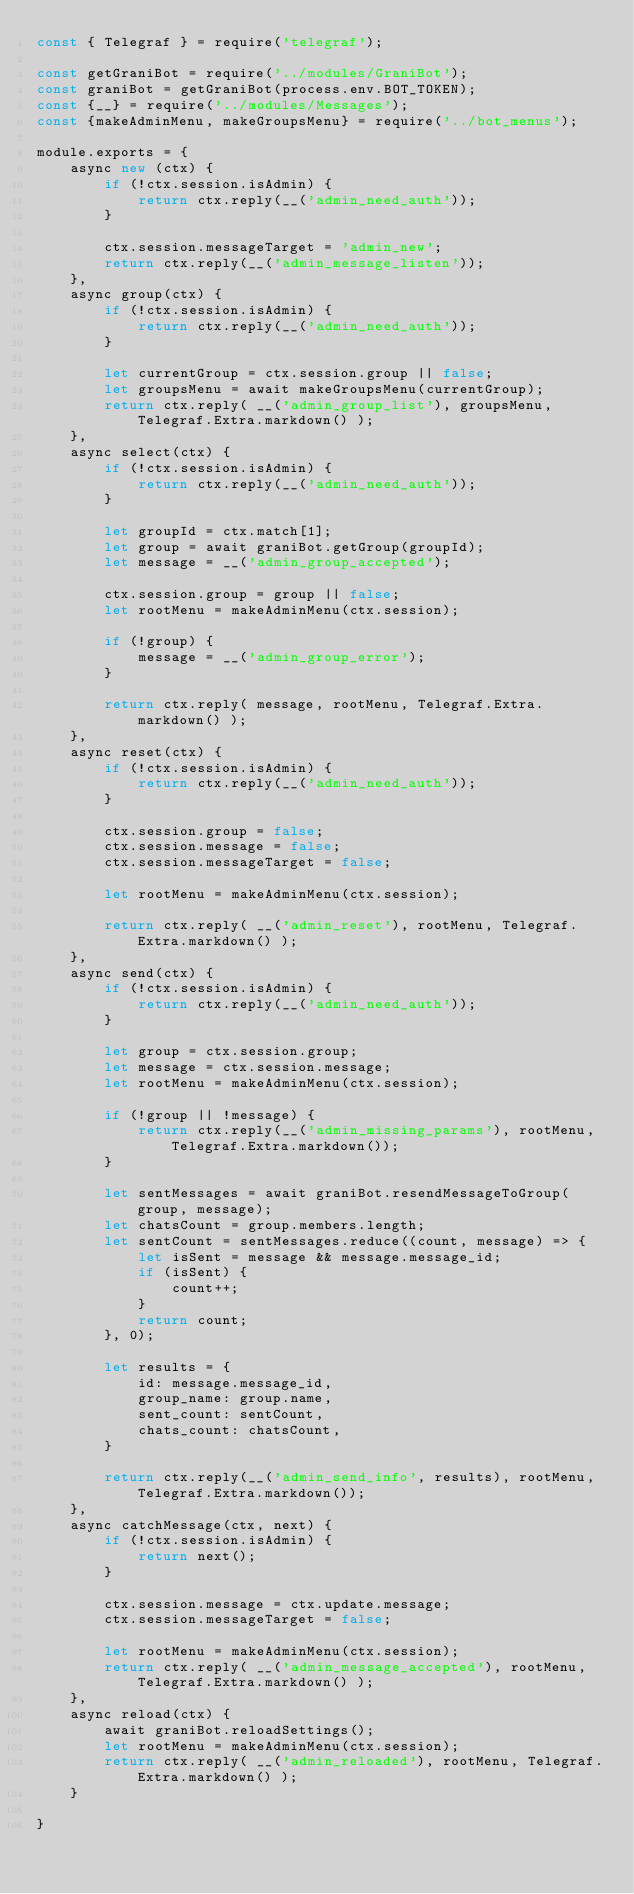<code> <loc_0><loc_0><loc_500><loc_500><_JavaScript_>const { Telegraf } = require('telegraf');

const getGraniBot = require('../modules/GraniBot');
const graniBot = getGraniBot(process.env.BOT_TOKEN);
const {__} = require('../modules/Messages');
const {makeAdminMenu, makeGroupsMenu} = require('../bot_menus');

module.exports = {
    async new (ctx) {
        if (!ctx.session.isAdmin) {
            return ctx.reply(__('admin_need_auth'));
        }

        ctx.session.messageTarget = 'admin_new';
        return ctx.reply(__('admin_message_listen'));
    },
    async group(ctx) {
        if (!ctx.session.isAdmin) {
            return ctx.reply(__('admin_need_auth'));
        }

        let currentGroup = ctx.session.group || false;
        let groupsMenu = await makeGroupsMenu(currentGroup);
        return ctx.reply( __('admin_group_list'), groupsMenu, Telegraf.Extra.markdown() );
    },
    async select(ctx) {
        if (!ctx.session.isAdmin) {
            return ctx.reply(__('admin_need_auth'));
        }

        let groupId = ctx.match[1];
        let group = await graniBot.getGroup(groupId);
        let message = __('admin_group_accepted');

        ctx.session.group = group || false;
        let rootMenu = makeAdminMenu(ctx.session);

        if (!group) {
            message = __('admin_group_error');
        }

        return ctx.reply( message, rootMenu, Telegraf.Extra.markdown() );
    },
    async reset(ctx) {
        if (!ctx.session.isAdmin) {
            return ctx.reply(__('admin_need_auth'));
        }

        ctx.session.group = false;
        ctx.session.message = false;
        ctx.session.messageTarget = false;

        let rootMenu = makeAdminMenu(ctx.session);

        return ctx.reply( __('admin_reset'), rootMenu, Telegraf.Extra.markdown() );
    },
    async send(ctx) {
        if (!ctx.session.isAdmin) {
            return ctx.reply(__('admin_need_auth'));
        }

        let group = ctx.session.group;
        let message = ctx.session.message;
        let rootMenu = makeAdminMenu(ctx.session);

        if (!group || !message) {
            return ctx.reply(__('admin_missing_params'), rootMenu, Telegraf.Extra.markdown());
        }

        let sentMessages = await graniBot.resendMessageToGroup(group, message);
        let chatsCount = group.members.length;
        let sentCount = sentMessages.reduce((count, message) => {
            let isSent = message && message.message_id;
            if (isSent) {
                count++;
            }
            return count;
        }, 0);

        let results = {
            id: message.message_id,
            group_name: group.name,
            sent_count: sentCount,
            chats_count: chatsCount,
        }

        return ctx.reply(__('admin_send_info', results), rootMenu, Telegraf.Extra.markdown());
    },
    async catchMessage(ctx, next) {
        if (!ctx.session.isAdmin) {
            return next();
        }

        ctx.session.message = ctx.update.message;
        ctx.session.messageTarget = false;

        let rootMenu = makeAdminMenu(ctx.session);
        return ctx.reply( __('admin_message_accepted'), rootMenu, Telegraf.Extra.markdown() );
    },
    async reload(ctx) {
        await graniBot.reloadSettings();
        let rootMenu = makeAdminMenu(ctx.session);
        return ctx.reply( __('admin_reloaded'), rootMenu, Telegraf.Extra.markdown() );
    }

}</code> 